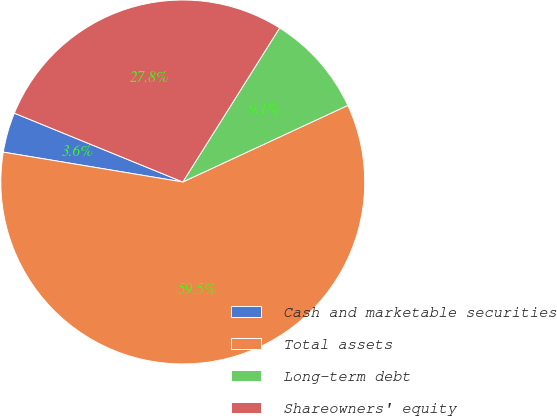Convert chart to OTSL. <chart><loc_0><loc_0><loc_500><loc_500><pie_chart><fcel>Cash and marketable securities<fcel>Total assets<fcel>Long-term debt<fcel>Shareowners' equity<nl><fcel>3.55%<fcel>59.54%<fcel>9.15%<fcel>27.76%<nl></chart> 